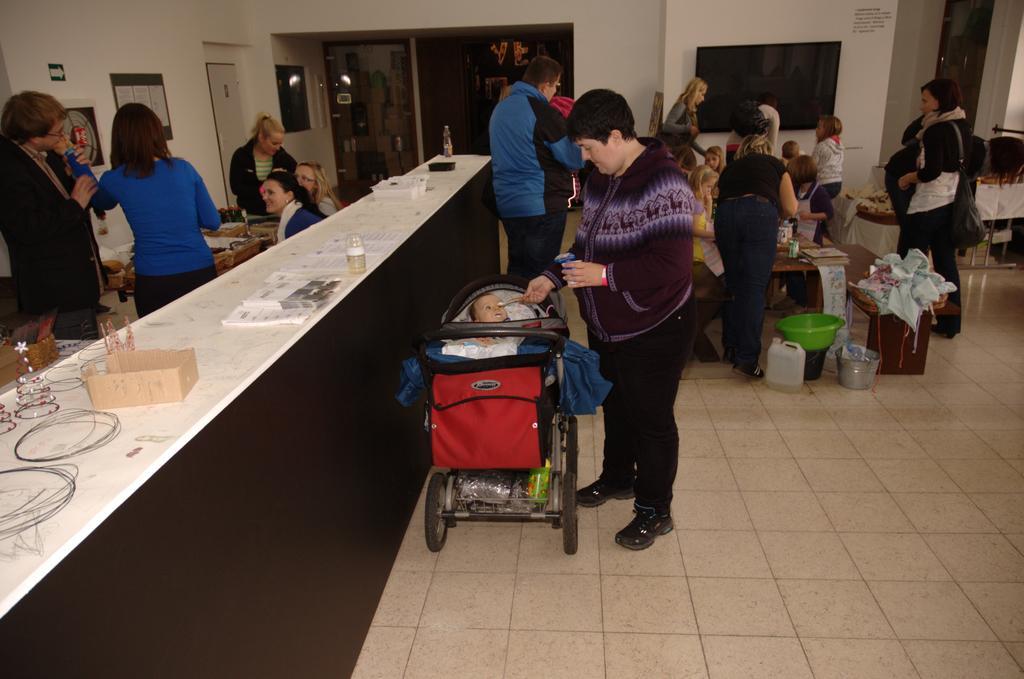Describe this image in one or two sentences. In this image we can see people, tables, papers, bottles, boxes, baby stroller, books, clothes, basket, and few objects. In the background we can see walls, television, boards, poster, door, and few objects. 